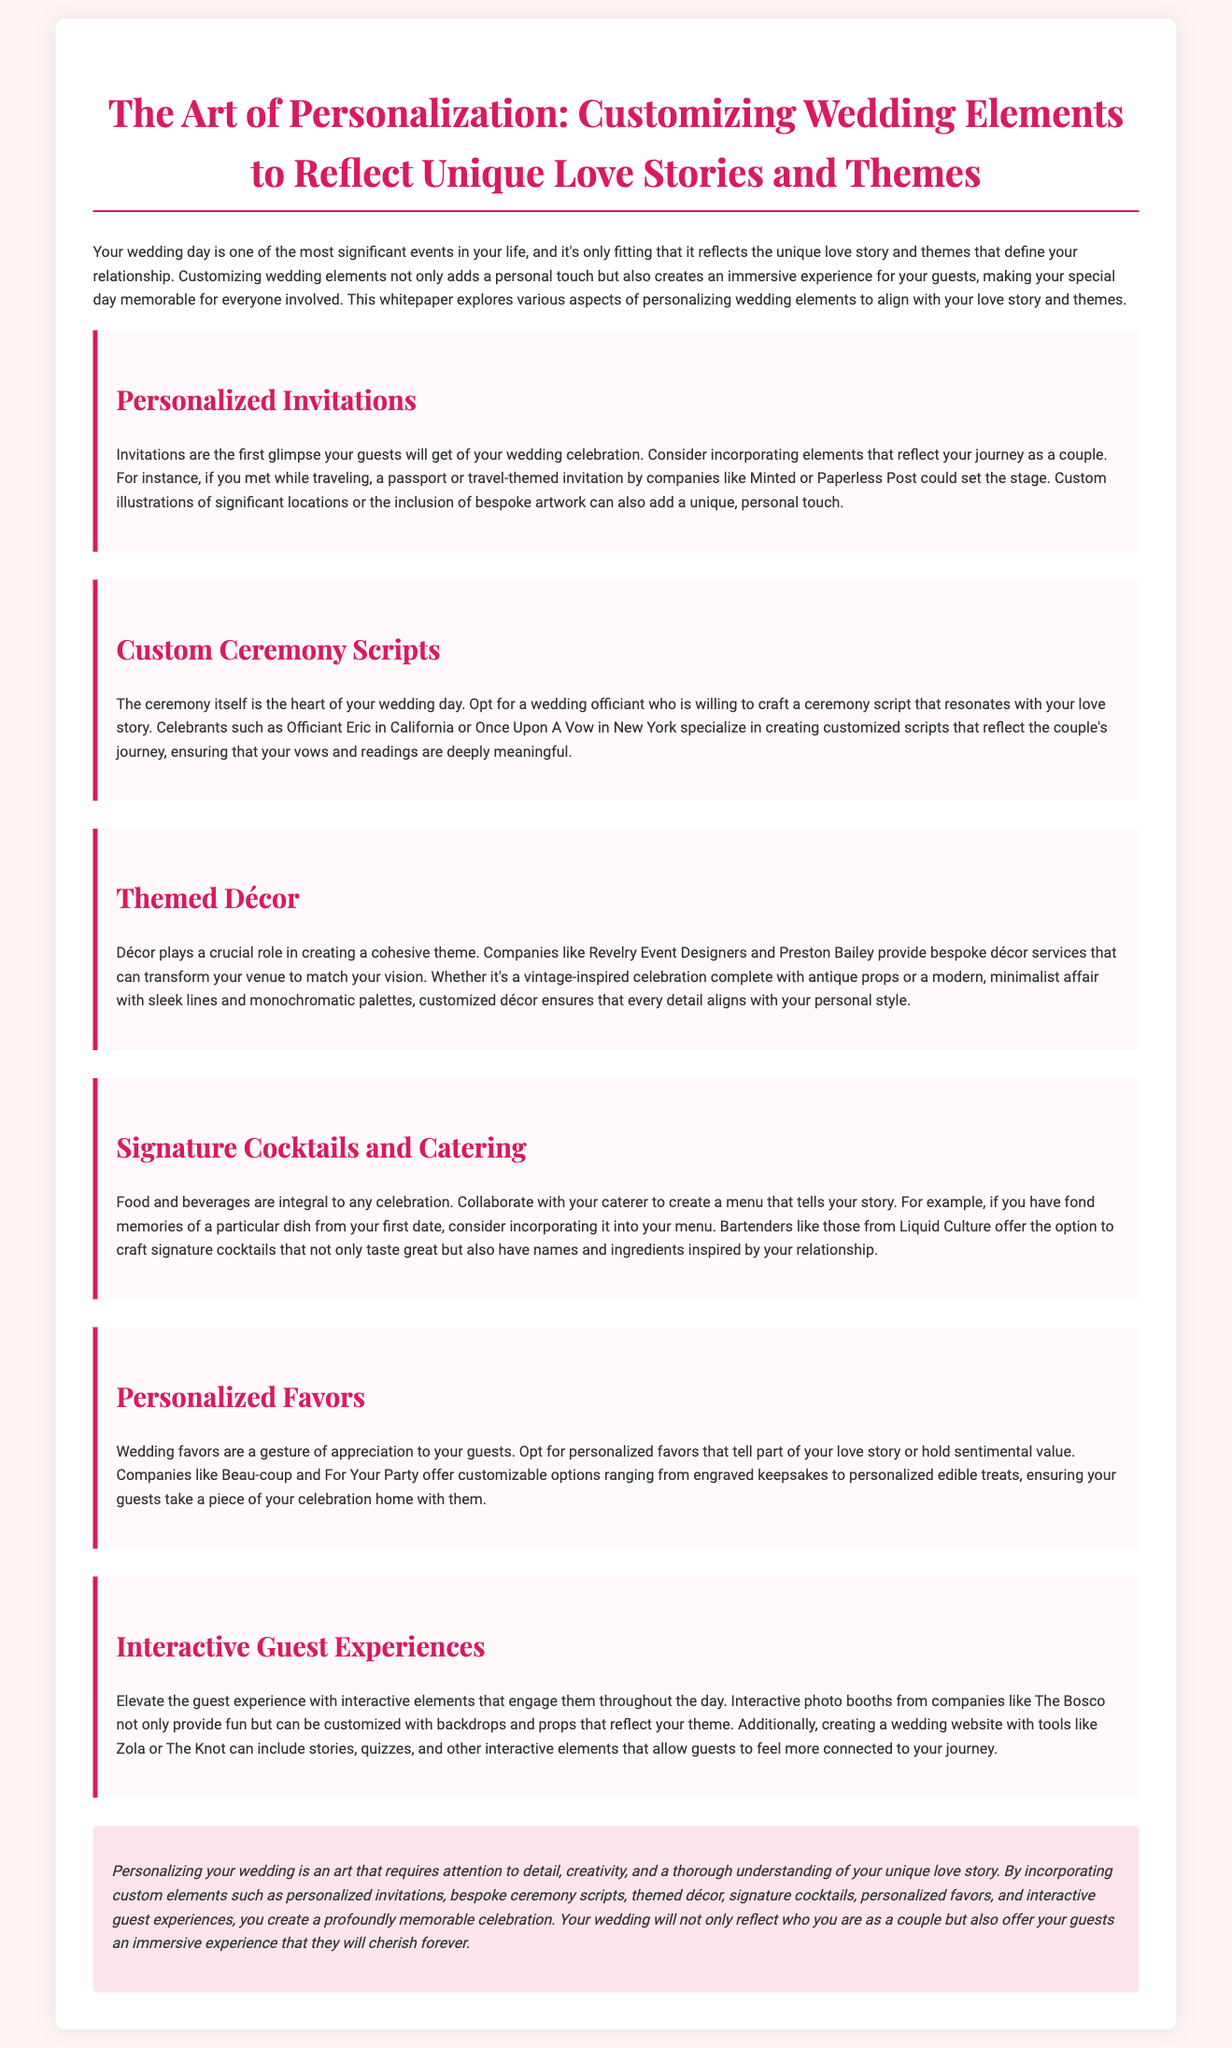what are the first elements guests see? The document states that invitations are the first glimpse your guests will get of your wedding celebration.
Answer: Invitations who are the companies mentioned for personalized invitations? The document lists Minted and Paperless Post as companies providing personalized invitations.
Answer: Minted, Paperless Post what is the heart of your wedding day? The document refers to the ceremony as the heart of your wedding day.
Answer: Ceremony which companies offer bespoke décor services? The companies mentioned for bespoke décor services in the document are Revelry Event Designers and Preston Bailey.
Answer: Revelry Event Designers, Preston Bailey what can personalized favors tell? The document explains that wedding favors can tell part of your love story or hold sentimental value.
Answer: Part of your love story what element can be customized for interactive guest experiences? The document suggests that interactive photo booths can be customized with backdrops and props that reflect your theme.
Answer: Backdrops and props who can craft signature cocktails? The document mentions that bartenders from Liquid Culture offer the option to craft signature cocktails.
Answer: Liquid Culture what is necessary for personalizing your wedding? According to the document, personalizing your wedding requires attention to detail, creativity, and a thorough understanding of your unique love story.
Answer: Attention to detail, creativity, understanding of your love story 